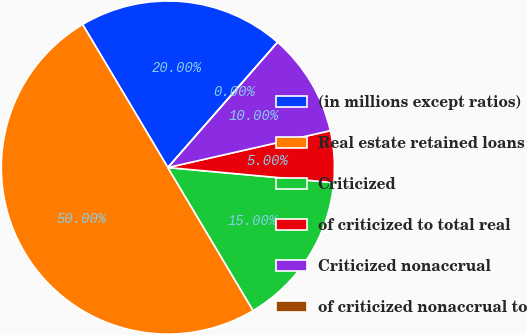Convert chart. <chart><loc_0><loc_0><loc_500><loc_500><pie_chart><fcel>(in millions except ratios)<fcel>Real estate retained loans<fcel>Criticized<fcel>of criticized to total real<fcel>Criticized nonaccrual<fcel>of criticized nonaccrual to<nl><fcel>20.0%<fcel>50.0%<fcel>15.0%<fcel>5.0%<fcel>10.0%<fcel>0.0%<nl></chart> 